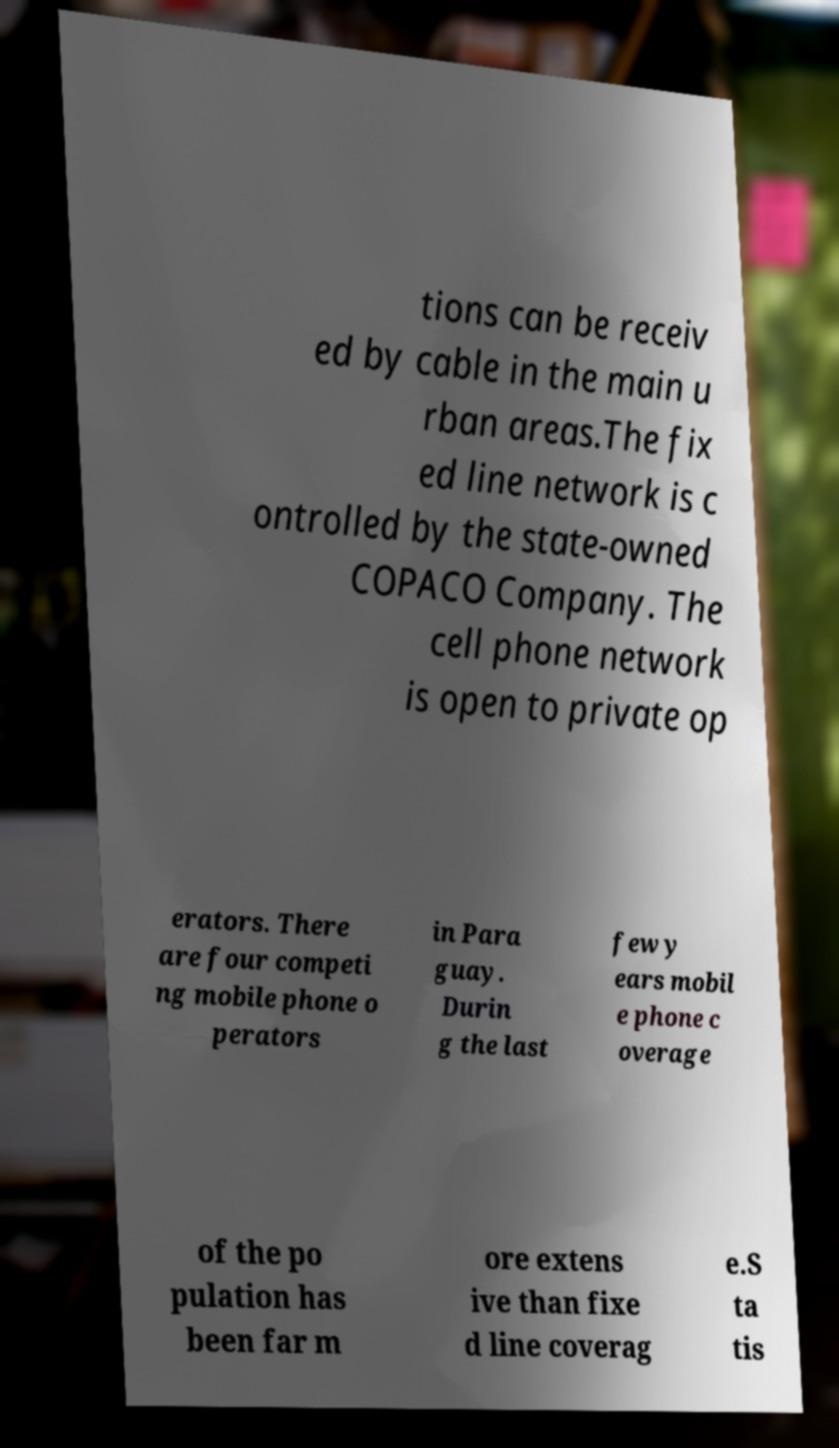Can you read and provide the text displayed in the image?This photo seems to have some interesting text. Can you extract and type it out for me? tions can be receiv ed by cable in the main u rban areas.The fix ed line network is c ontrolled by the state-owned COPACO Company. The cell phone network is open to private op erators. There are four competi ng mobile phone o perators in Para guay. Durin g the last few y ears mobil e phone c overage of the po pulation has been far m ore extens ive than fixe d line coverag e.S ta tis 